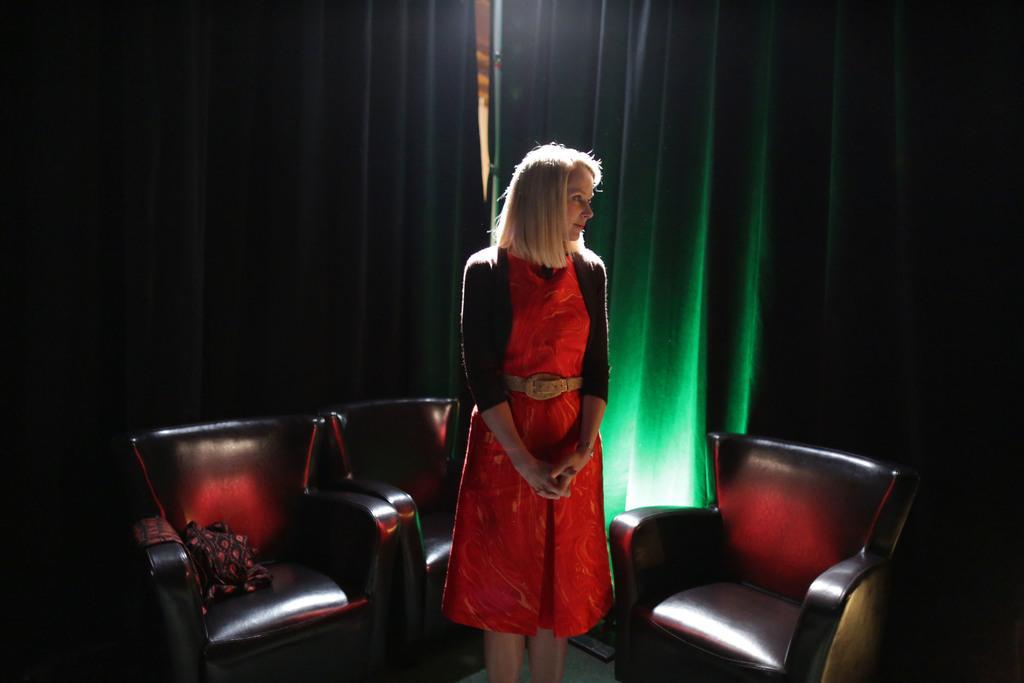Please provide a concise description of this image. In this image, a woman wear a red color dress. She stand in the middle. Beside her, we can see few black chairs. On the left side chair, we can see some cloth. The background, we can see green color curtain. 